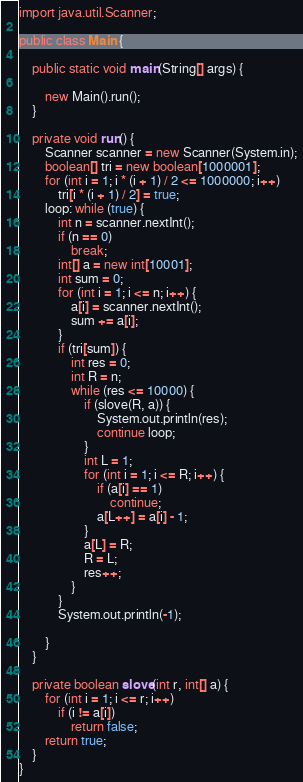Convert code to text. <code><loc_0><loc_0><loc_500><loc_500><_Java_>
import java.util.Scanner;

public class Main {

	public static void main(String[] args) {

		new Main().run();
	}

	private void run() {
		Scanner scanner = new Scanner(System.in);
		boolean[] tri = new boolean[1000001];
		for (int i = 1; i * (i + 1) / 2 <= 1000000; i++)
			tri[i * (i + 1) / 2] = true;
		loop: while (true) {
			int n = scanner.nextInt();
			if (n == 0)
				break;
			int[] a = new int[10001];
			int sum = 0;
			for (int i = 1; i <= n; i++) {
				a[i] = scanner.nextInt();
				sum += a[i];
			}
			if (tri[sum]) {
				int res = 0;
				int R = n;
				while (res <= 10000) {
					if (slove(R, a)) {
						System.out.println(res);
						continue loop;
					}
					int L = 1;
					for (int i = 1; i <= R; i++) {
						if (a[i] == 1)
							continue;
						a[L++] = a[i] - 1;
					}
					a[L] = R;
					R = L;
					res++;
				}
			}
			System.out.println(-1);

		}
	}

	private boolean slove(int r, int[] a) {
		for (int i = 1; i <= r; i++)
			if (i != a[i])
				return false;
		return true;
	}
}</code> 